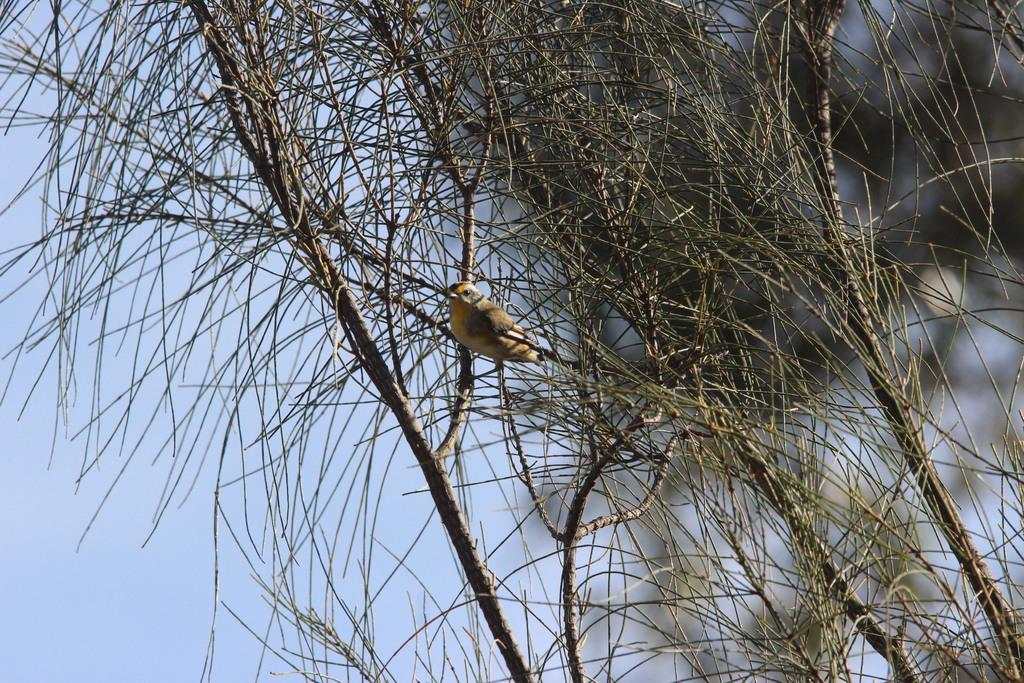What type of animal can be seen in the image? There is a bird in the image. Where is the bird located? The bird is on the branch of a small tree. What is the color of the bird? The bird is in brown color. What can be seen in the background of the image? There is a sky visible in the background of the image. What type of pies is the bird eating in the image? There are no pies present in the image, and the bird is not shown eating anything. 